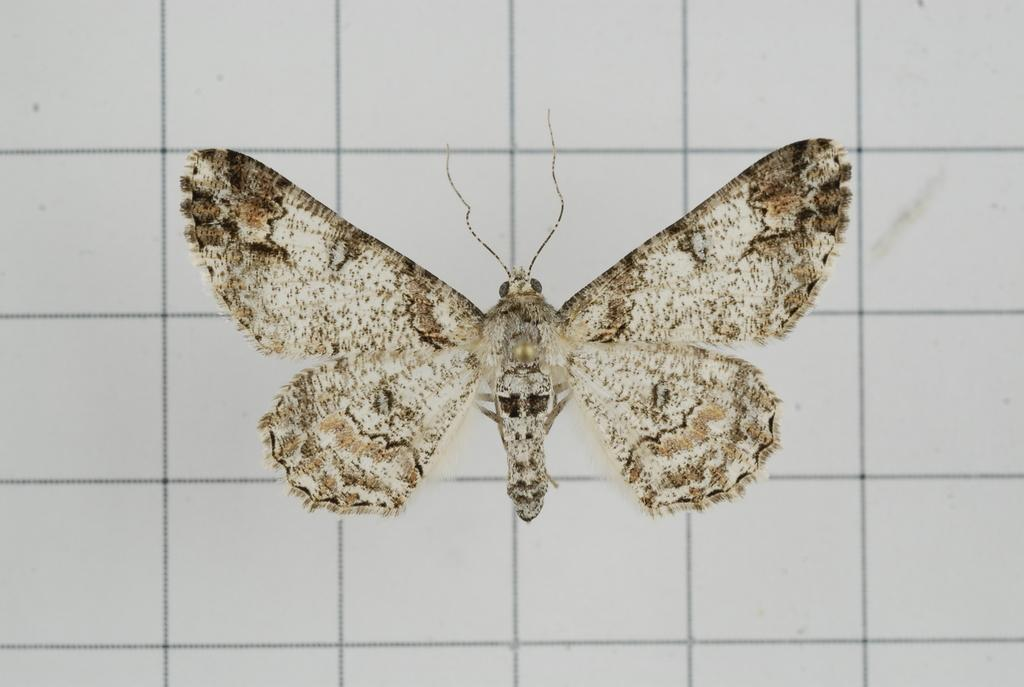What is the main subject of the image? The main subject of the image is a butterfly. What is the color of the surface on which the butterfly is resting? The butterfly is on a white surface. What type of lettuce can be seen growing in the image? There is no lettuce present in the image; it features a butterfly on a white surface. How does the bat contribute to the pollution in the image? There is no bat or pollution present in the image. 